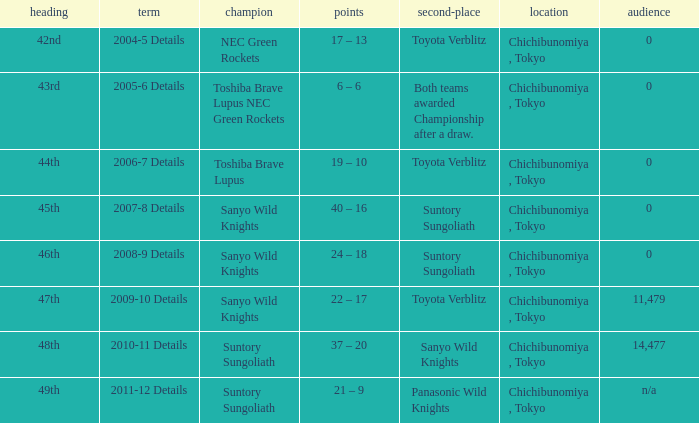What is the Attendance number for the title of 44th? 0.0. 